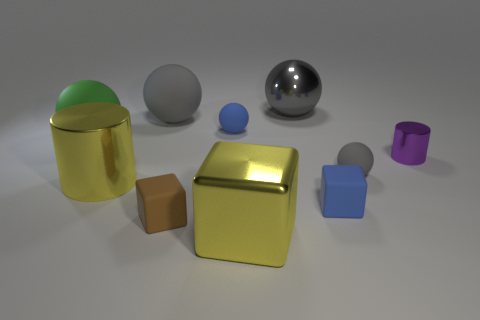How many gray spheres must be subtracted to get 1 gray spheres? 2 Subtract all cyan cylinders. How many gray balls are left? 3 Subtract all blue rubber balls. How many balls are left? 4 Subtract all purple balls. Subtract all gray blocks. How many balls are left? 5 Subtract all cubes. How many objects are left? 7 Add 8 tiny purple objects. How many tiny purple objects are left? 9 Add 1 large red rubber things. How many large red rubber things exist? 1 Subtract 0 blue cylinders. How many objects are left? 10 Subtract all large gray matte things. Subtract all large metallic cylinders. How many objects are left? 8 